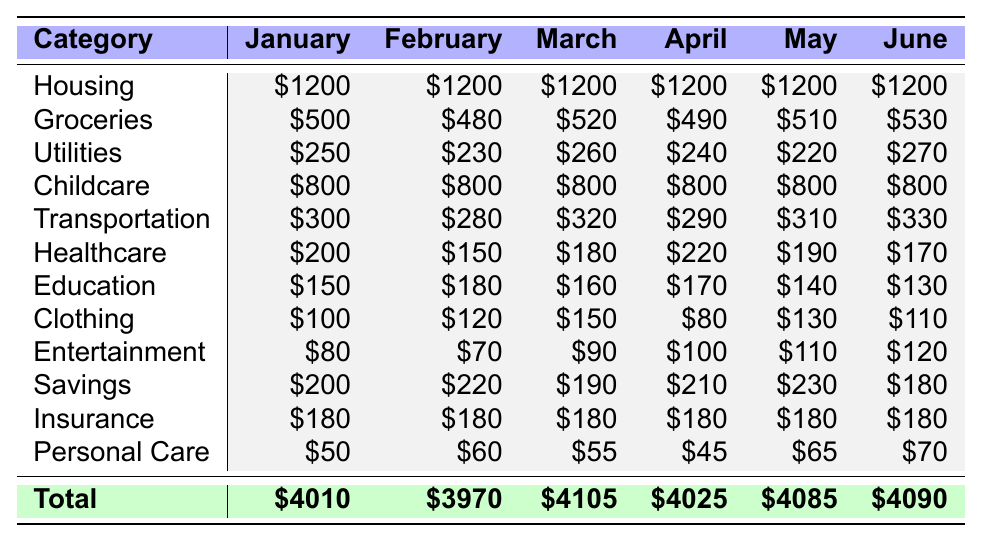What was the total expense for January? To find the total expense for January, I sum all the expenses in that month: Housing (1200) + Groceries (500) + Utilities (250) + Childcare (800) + Transportation (300) + Healthcare (200) + Education (150) + Clothing (100) + Entertainment (80) + Savings (200) + Insurance (180) + Personal Care (50) = 4010.
Answer: 4010 Which month had the highest expenses? Looking at the total expenses for each month, January had a total of 4010, February had 3970, March had 4105, April had 4025, May had 4085, and June had 4090. The month with the highest total is March at 4105.
Answer: March How much did I spend on groceries in April? The table shows that expenses for groceries in April amounted to 490.
Answer: 490 What is the difference in childcare costs between January and June? In January, childcare costs were 800 and in June the costs remained 800. The difference is 800 - 800 = 0.
Answer: 0 What is the average expense for transportation from January to June? The transportation expenses for the months are: 300 (January), 280 (February), 320 (March), 290 (April), 310 (May), and 330 (June). Summing these gives 300 + 280 + 320 + 290 + 310 + 330 = 1830. There are 6 months, so the average is 1830 / 6 = 305.
Answer: 305 Is healthcare spending higher in April than in February? In February, healthcare spending was 150, and in April it was 220. Since 220 is greater than 150, healthcare spending is indeed higher in April than in February.
Answer: Yes What category had the most variability in expenses over the six months? Looking at the expense amounts across months: Groceries range from 480 to 530 (difference of 50), Utilities range from 220 to 270 (difference of 50), Clothing range from 80 to 150 (difference of 70), and so on. The greatest difference can be seen in Clothing (80 to 150), leading to a variability of 70, which is larger than the others.
Answer: Clothing What was the total savings from January to June? The savings for each month were: 200 (January), 220 (February), 190 (March), 210 (April), 230 (May), and 180 (June). The total savings are 200 + 220 + 190 + 210 + 230 + 180 = 1230.
Answer: 1230 In which month did the expenditure on personal care drop the most compared to the previous month? Personal care costs were: 50 (January), 60 (February), 55 (March), 45 (April), 65 (May), and 70 (June). The decrease from March to April was the most significant: 55 - 45 = 10.
Answer: April What is the total spent on education over the six months? The education expenses for each month were: 150 (January), 180 (February), 160 (March), 170 (April), 140 (May), and 130 (June). Summing these amounts gives 150 + 180 + 160 + 170 + 140 + 130 = 1030.
Answer: 1030 